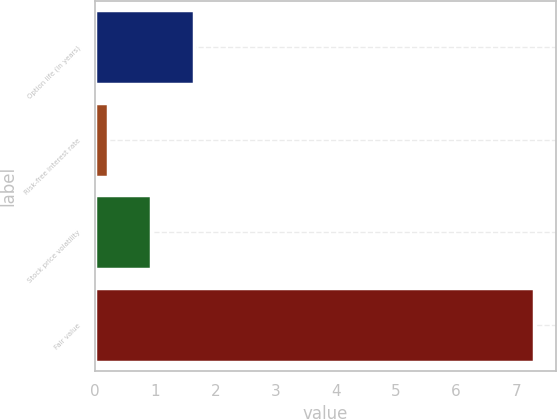Convert chart to OTSL. <chart><loc_0><loc_0><loc_500><loc_500><bar_chart><fcel>Option life (in years)<fcel>Risk-free interest rate<fcel>Stock price volatility<fcel>Fair value<nl><fcel>1.64<fcel>0.22<fcel>0.93<fcel>7.29<nl></chart> 